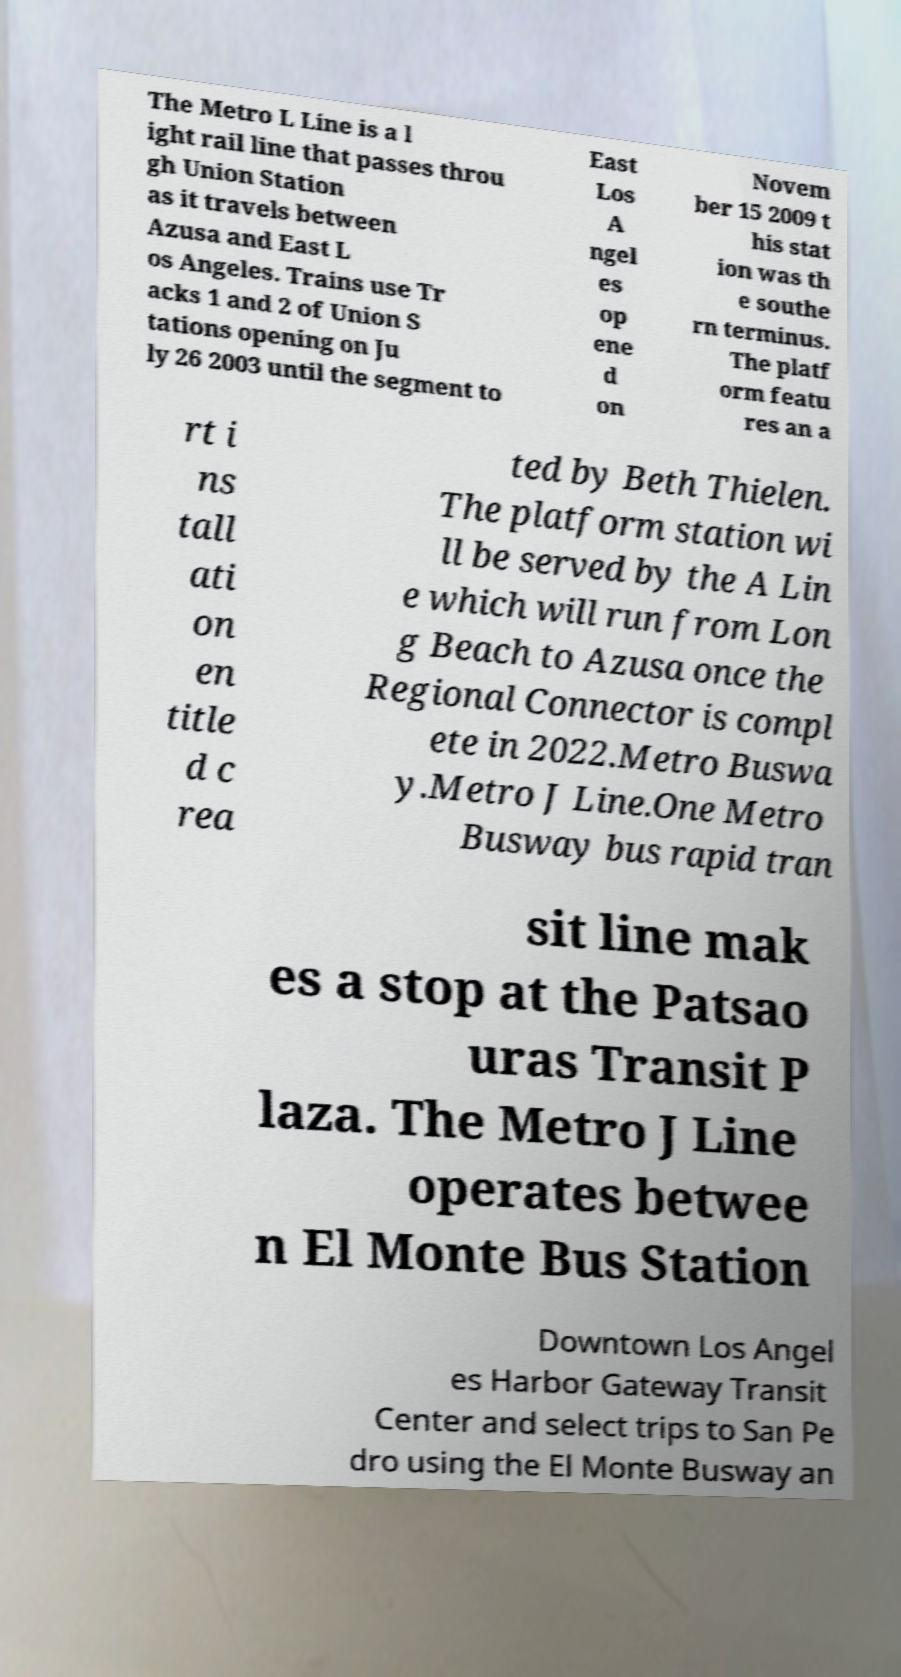Please read and relay the text visible in this image. What does it say? The Metro L Line is a l ight rail line that passes throu gh Union Station as it travels between Azusa and East L os Angeles. Trains use Tr acks 1 and 2 of Union S tations opening on Ju ly 26 2003 until the segment to East Los A ngel es op ene d on Novem ber 15 2009 t his stat ion was th e southe rn terminus. The platf orm featu res an a rt i ns tall ati on en title d c rea ted by Beth Thielen. The platform station wi ll be served by the A Lin e which will run from Lon g Beach to Azusa once the Regional Connector is compl ete in 2022.Metro Buswa y.Metro J Line.One Metro Busway bus rapid tran sit line mak es a stop at the Patsao uras Transit P laza. The Metro J Line operates betwee n El Monte Bus Station Downtown Los Angel es Harbor Gateway Transit Center and select trips to San Pe dro using the El Monte Busway an 